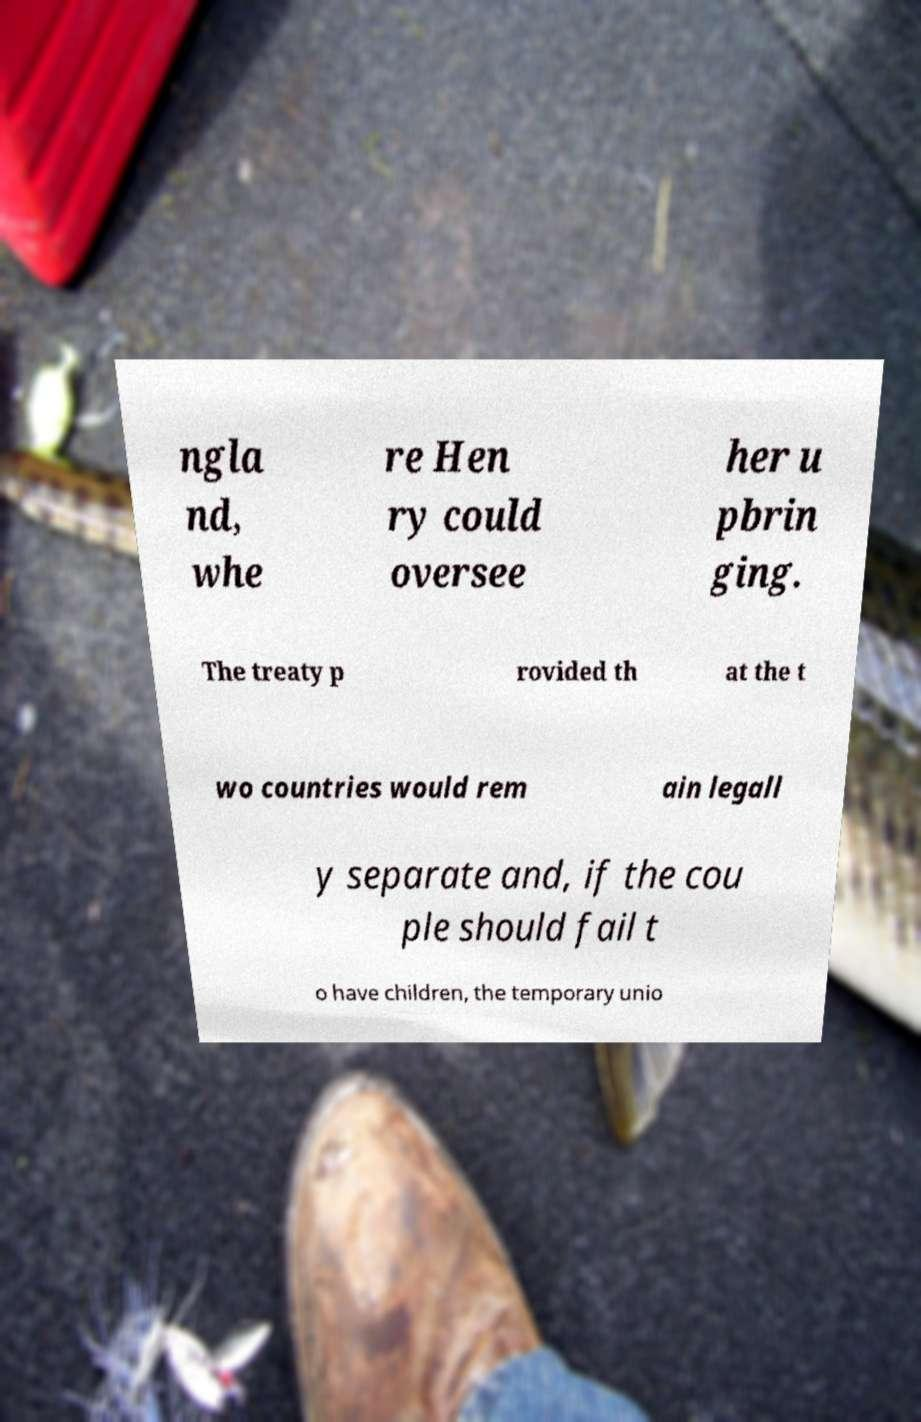Please read and relay the text visible in this image. What does it say? ngla nd, whe re Hen ry could oversee her u pbrin ging. The treaty p rovided th at the t wo countries would rem ain legall y separate and, if the cou ple should fail t o have children, the temporary unio 